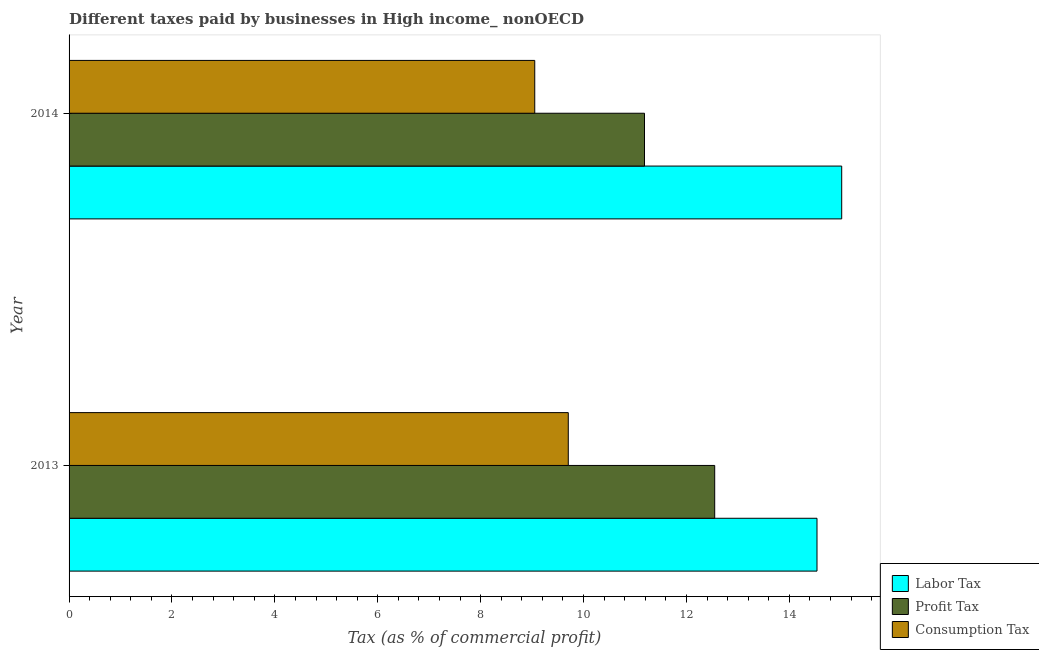How many different coloured bars are there?
Give a very brief answer. 3. Are the number of bars per tick equal to the number of legend labels?
Provide a succinct answer. Yes. Are the number of bars on each tick of the Y-axis equal?
Give a very brief answer. Yes. How many bars are there on the 1st tick from the bottom?
Offer a terse response. 3. What is the label of the 2nd group of bars from the top?
Keep it short and to the point. 2013. What is the percentage of consumption tax in 2014?
Offer a terse response. 9.05. Across all years, what is the maximum percentage of consumption tax?
Offer a very short reply. 9.7. Across all years, what is the minimum percentage of consumption tax?
Your answer should be compact. 9.05. In which year was the percentage of labor tax maximum?
Provide a succinct answer. 2014. What is the total percentage of labor tax in the graph?
Keep it short and to the point. 29.56. What is the difference between the percentage of consumption tax in 2013 and that in 2014?
Give a very brief answer. 0.65. What is the difference between the percentage of profit tax in 2013 and the percentage of consumption tax in 2014?
Make the answer very short. 3.5. What is the average percentage of consumption tax per year?
Make the answer very short. 9.38. In the year 2014, what is the difference between the percentage of profit tax and percentage of labor tax?
Offer a terse response. -3.83. What is the ratio of the percentage of profit tax in 2013 to that in 2014?
Your answer should be very brief. 1.12. Is the percentage of profit tax in 2013 less than that in 2014?
Offer a very short reply. No. Is the difference between the percentage of labor tax in 2013 and 2014 greater than the difference between the percentage of consumption tax in 2013 and 2014?
Provide a succinct answer. No. In how many years, is the percentage of labor tax greater than the average percentage of labor tax taken over all years?
Provide a short and direct response. 1. What does the 1st bar from the top in 2013 represents?
Offer a very short reply. Consumption Tax. What does the 1st bar from the bottom in 2013 represents?
Your response must be concise. Labor Tax. Is it the case that in every year, the sum of the percentage of labor tax and percentage of profit tax is greater than the percentage of consumption tax?
Provide a short and direct response. Yes. How many bars are there?
Give a very brief answer. 6. What is the difference between two consecutive major ticks on the X-axis?
Give a very brief answer. 2. Are the values on the major ticks of X-axis written in scientific E-notation?
Provide a short and direct response. No. How are the legend labels stacked?
Your response must be concise. Vertical. What is the title of the graph?
Offer a terse response. Different taxes paid by businesses in High income_ nonOECD. Does "Negligence towards kids" appear as one of the legend labels in the graph?
Your answer should be very brief. No. What is the label or title of the X-axis?
Your response must be concise. Tax (as % of commercial profit). What is the label or title of the Y-axis?
Keep it short and to the point. Year. What is the Tax (as % of commercial profit) of Labor Tax in 2013?
Keep it short and to the point. 14.54. What is the Tax (as % of commercial profit) of Profit Tax in 2013?
Offer a very short reply. 12.55. What is the Tax (as % of commercial profit) of Consumption Tax in 2013?
Make the answer very short. 9.7. What is the Tax (as % of commercial profit) in Labor Tax in 2014?
Keep it short and to the point. 15.02. What is the Tax (as % of commercial profit) in Profit Tax in 2014?
Offer a very short reply. 11.19. What is the Tax (as % of commercial profit) of Consumption Tax in 2014?
Give a very brief answer. 9.05. Across all years, what is the maximum Tax (as % of commercial profit) of Labor Tax?
Provide a short and direct response. 15.02. Across all years, what is the maximum Tax (as % of commercial profit) of Profit Tax?
Keep it short and to the point. 12.55. Across all years, what is the maximum Tax (as % of commercial profit) of Consumption Tax?
Provide a short and direct response. 9.7. Across all years, what is the minimum Tax (as % of commercial profit) of Labor Tax?
Your response must be concise. 14.54. Across all years, what is the minimum Tax (as % of commercial profit) in Profit Tax?
Your answer should be very brief. 11.19. Across all years, what is the minimum Tax (as % of commercial profit) of Consumption Tax?
Provide a short and direct response. 9.05. What is the total Tax (as % of commercial profit) of Labor Tax in the graph?
Your response must be concise. 29.56. What is the total Tax (as % of commercial profit) in Profit Tax in the graph?
Your answer should be very brief. 23.74. What is the total Tax (as % of commercial profit) in Consumption Tax in the graph?
Your response must be concise. 18.76. What is the difference between the Tax (as % of commercial profit) in Labor Tax in 2013 and that in 2014?
Provide a succinct answer. -0.48. What is the difference between the Tax (as % of commercial profit) of Profit Tax in 2013 and that in 2014?
Your answer should be very brief. 1.36. What is the difference between the Tax (as % of commercial profit) of Consumption Tax in 2013 and that in 2014?
Provide a succinct answer. 0.65. What is the difference between the Tax (as % of commercial profit) in Labor Tax in 2013 and the Tax (as % of commercial profit) in Profit Tax in 2014?
Keep it short and to the point. 3.35. What is the difference between the Tax (as % of commercial profit) of Labor Tax in 2013 and the Tax (as % of commercial profit) of Consumption Tax in 2014?
Keep it short and to the point. 5.49. What is the difference between the Tax (as % of commercial profit) of Profit Tax in 2013 and the Tax (as % of commercial profit) of Consumption Tax in 2014?
Provide a succinct answer. 3.5. What is the average Tax (as % of commercial profit) of Labor Tax per year?
Your answer should be very brief. 14.78. What is the average Tax (as % of commercial profit) of Profit Tax per year?
Offer a very short reply. 11.87. What is the average Tax (as % of commercial profit) in Consumption Tax per year?
Give a very brief answer. 9.38. In the year 2013, what is the difference between the Tax (as % of commercial profit) in Labor Tax and Tax (as % of commercial profit) in Profit Tax?
Offer a terse response. 1.99. In the year 2013, what is the difference between the Tax (as % of commercial profit) of Labor Tax and Tax (as % of commercial profit) of Consumption Tax?
Offer a very short reply. 4.83. In the year 2013, what is the difference between the Tax (as % of commercial profit) of Profit Tax and Tax (as % of commercial profit) of Consumption Tax?
Your response must be concise. 2.85. In the year 2014, what is the difference between the Tax (as % of commercial profit) of Labor Tax and Tax (as % of commercial profit) of Profit Tax?
Your answer should be very brief. 3.83. In the year 2014, what is the difference between the Tax (as % of commercial profit) in Labor Tax and Tax (as % of commercial profit) in Consumption Tax?
Your answer should be compact. 5.97. In the year 2014, what is the difference between the Tax (as % of commercial profit) in Profit Tax and Tax (as % of commercial profit) in Consumption Tax?
Your response must be concise. 2.13. What is the ratio of the Tax (as % of commercial profit) in Profit Tax in 2013 to that in 2014?
Provide a succinct answer. 1.12. What is the ratio of the Tax (as % of commercial profit) in Consumption Tax in 2013 to that in 2014?
Ensure brevity in your answer.  1.07. What is the difference between the highest and the second highest Tax (as % of commercial profit) in Labor Tax?
Your response must be concise. 0.48. What is the difference between the highest and the second highest Tax (as % of commercial profit) in Profit Tax?
Provide a succinct answer. 1.36. What is the difference between the highest and the second highest Tax (as % of commercial profit) of Consumption Tax?
Keep it short and to the point. 0.65. What is the difference between the highest and the lowest Tax (as % of commercial profit) in Labor Tax?
Provide a short and direct response. 0.48. What is the difference between the highest and the lowest Tax (as % of commercial profit) in Profit Tax?
Your answer should be very brief. 1.36. What is the difference between the highest and the lowest Tax (as % of commercial profit) in Consumption Tax?
Your response must be concise. 0.65. 